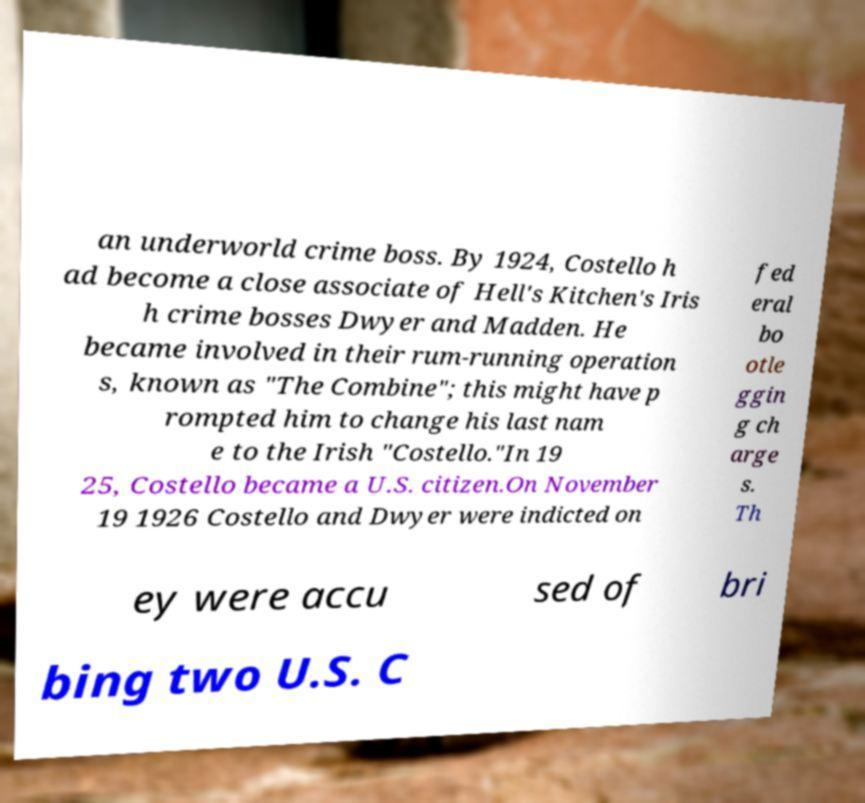What messages or text are displayed in this image? I need them in a readable, typed format. an underworld crime boss. By 1924, Costello h ad become a close associate of Hell's Kitchen's Iris h crime bosses Dwyer and Madden. He became involved in their rum-running operation s, known as "The Combine"; this might have p rompted him to change his last nam e to the Irish "Costello."In 19 25, Costello became a U.S. citizen.On November 19 1926 Costello and Dwyer were indicted on fed eral bo otle ggin g ch arge s. Th ey were accu sed of bri bing two U.S. C 